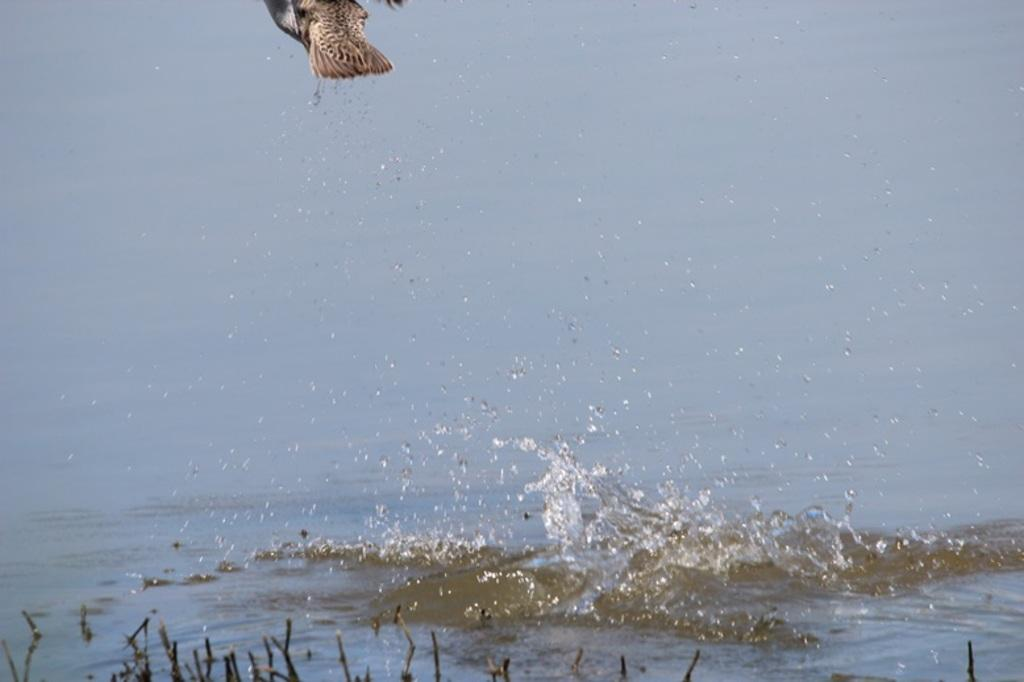What is flying in the air in the image? There is a bird in the air in the image. What can be seen in the background of the image? There is water visible in the image. What is located at the bottom side of the image? There are objects present at the bottom side of the image. What type of system is being used to control the clocks in the image? There are no clocks present in the image, so it is not possible to determine what type of system might be used to control them. 